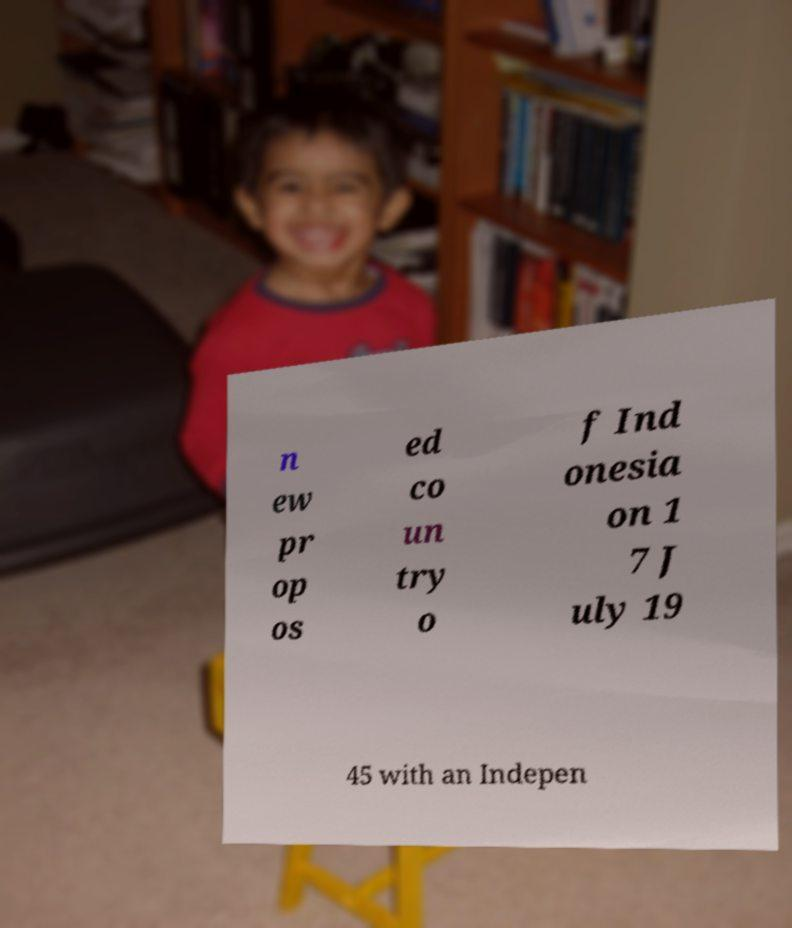Could you assist in decoding the text presented in this image and type it out clearly? n ew pr op os ed co un try o f Ind onesia on 1 7 J uly 19 45 with an Indepen 